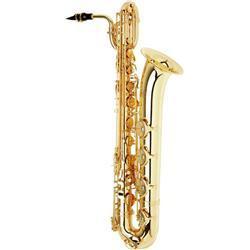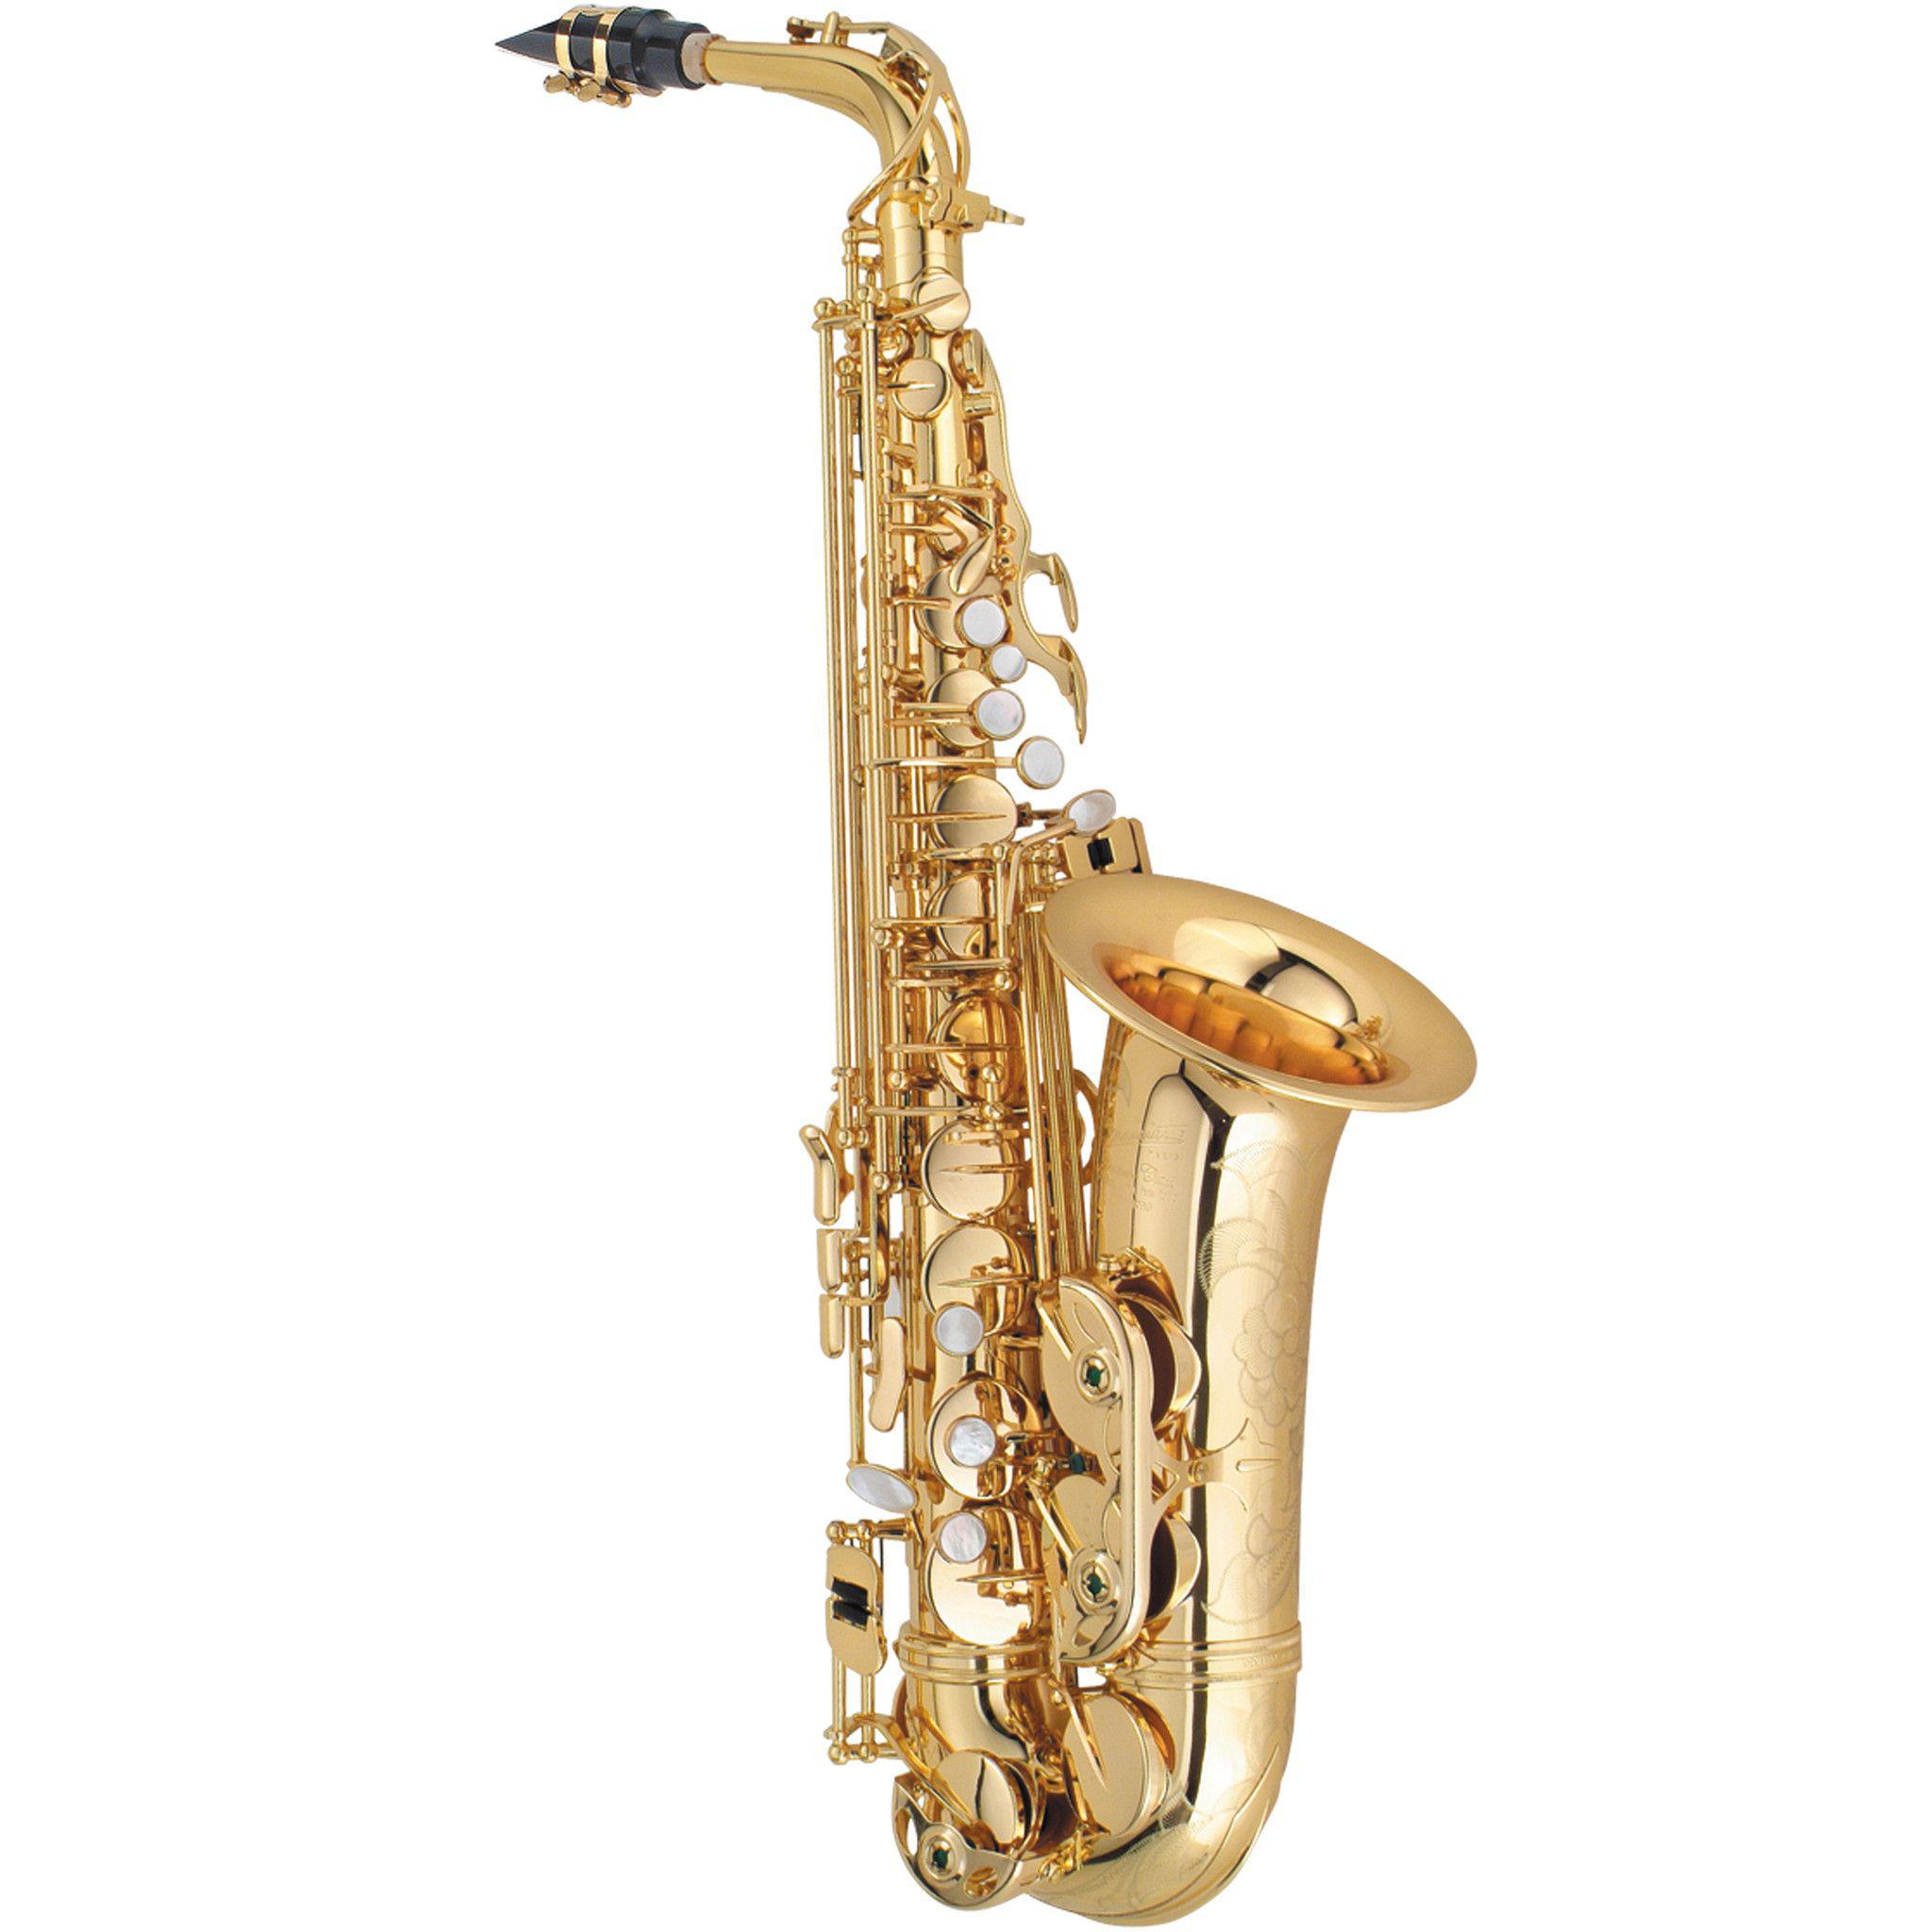The first image is the image on the left, the second image is the image on the right. For the images displayed, is the sentence "The sax on the left is missing a mouthpiece." factually correct? Answer yes or no. No. The first image is the image on the left, the second image is the image on the right. Analyze the images presented: Is the assertion "The saxophone on the left has a black mouthpiece and is displayed vertically, while the saxophone on the right has no dark mouthpiece and is tilted to the right." valid? Answer yes or no. No. 